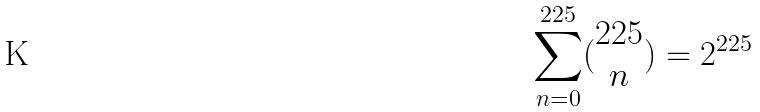<formula> <loc_0><loc_0><loc_500><loc_500>\sum _ { n = 0 } ^ { 2 2 5 } ( \begin{matrix} 2 2 5 \\ n \end{matrix} ) = 2 ^ { 2 2 5 }</formula> 